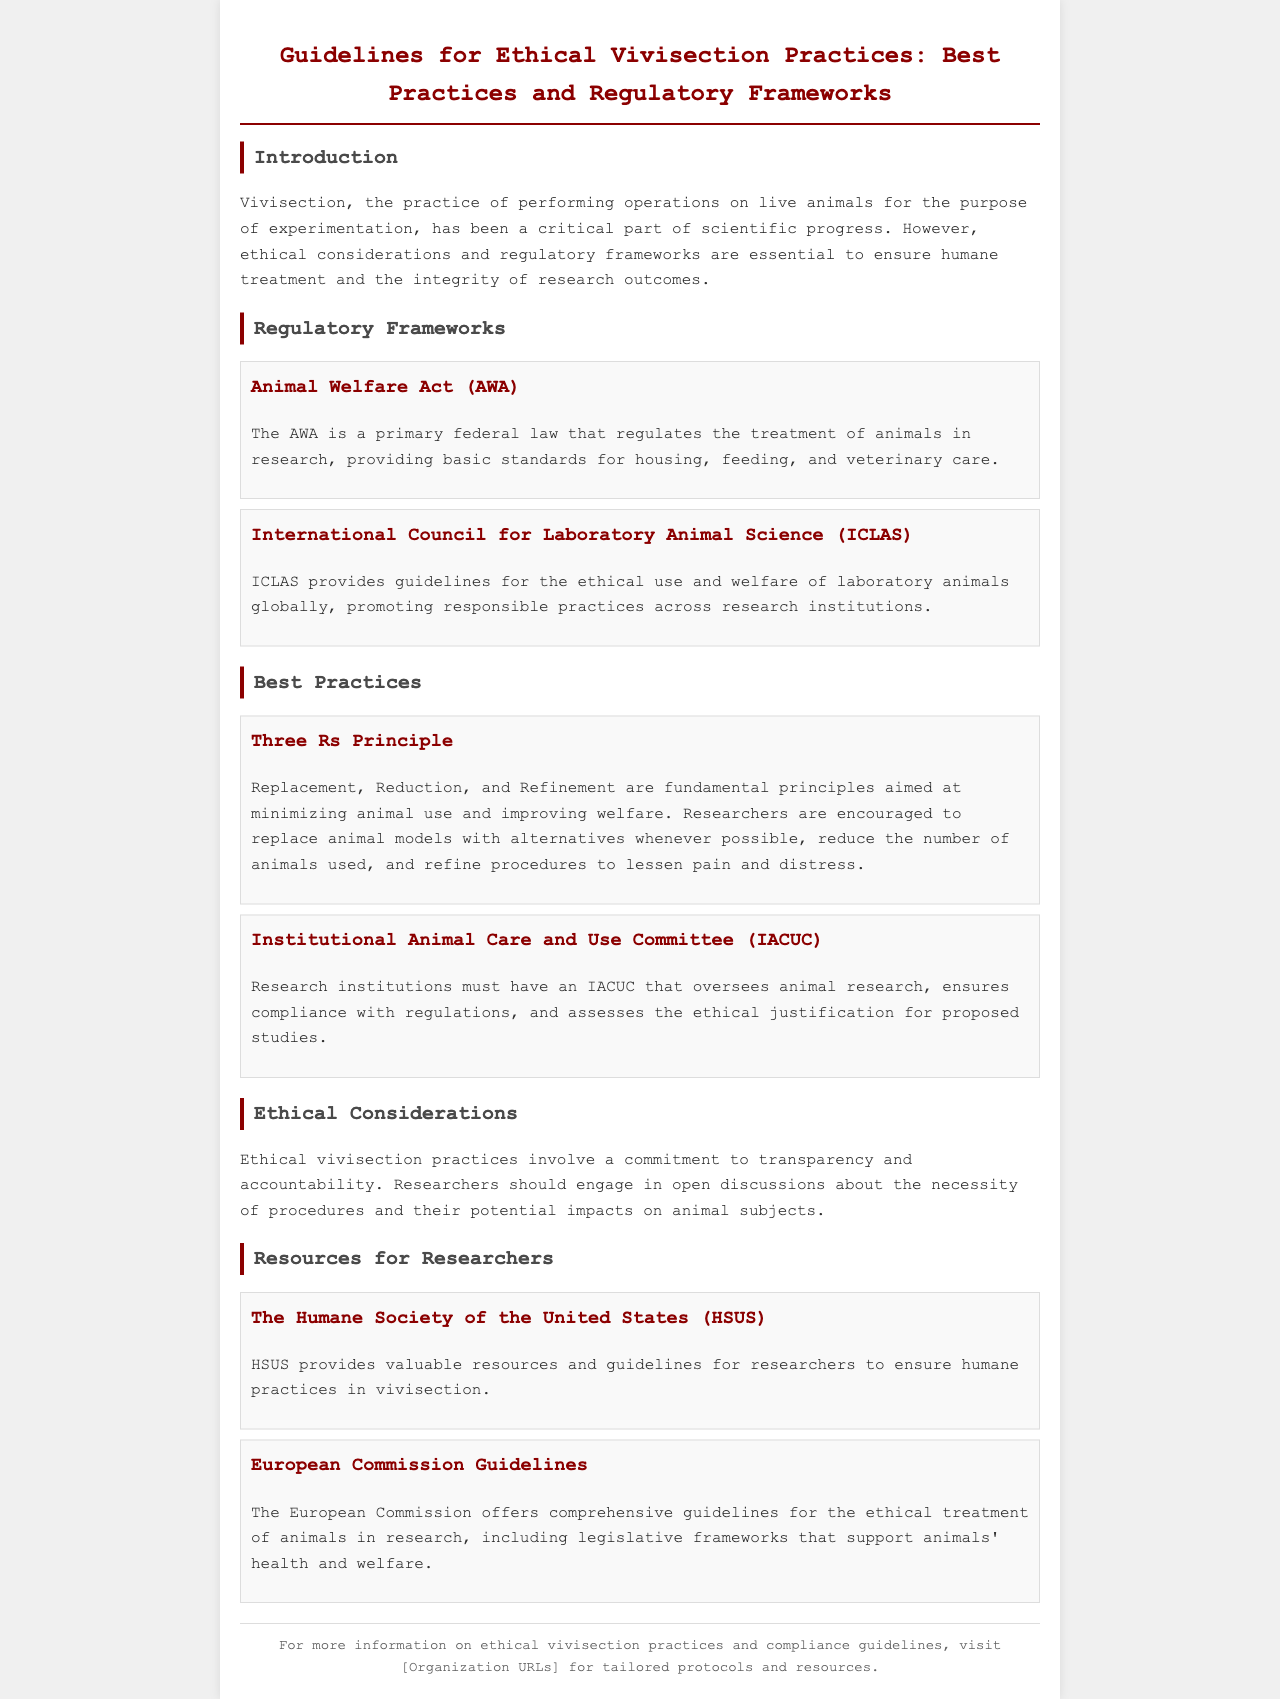What is vivisection? Vivisection is defined in the document as the practice of performing operations on live animals for the purpose of experimentation.
Answer: performing operations on live animals for the purpose of experimentation What does AWA stand for? The acronym AWA stands for the Animal Welfare Act, which is mentioned in the Regulatory Frameworks section.
Answer: Animal Welfare Act What are the Three Rs? The Three Rs are fundamental principles discussed under Best Practices aimed at minimizing animal use and improving welfare.
Answer: Replacement, Reduction, Refinement What does IACUC stand for? IACUC stands for the Institutional Animal Care and Use Committee, which is detailed in the Best Practices section.
Answer: Institutional Animal Care and Use Committee Which organization provides resources for humane practices in vivisection? The brochure mentions the Humane Society of the United States (HSUS) as a resource provider.
Answer: Humane Society of the United States What is the focus of the International Council for Laboratory Animal Science? The ICLAS focuses on providing guidelines for the ethical use and welfare of laboratory animals globally.
Answer: ethical use and welfare of laboratory animals globally What is a key ethical consideration in vivisection practices? A key ethical consideration mentioned is the commitment to transparency and accountability in research practices.
Answer: transparency and accountability What is emphasized in the European Commission Guidelines? The European Commission Guidelines emphasize comprehensive guidelines for the ethical treatment of animals in research.
Answer: ethical treatment of animals in research 